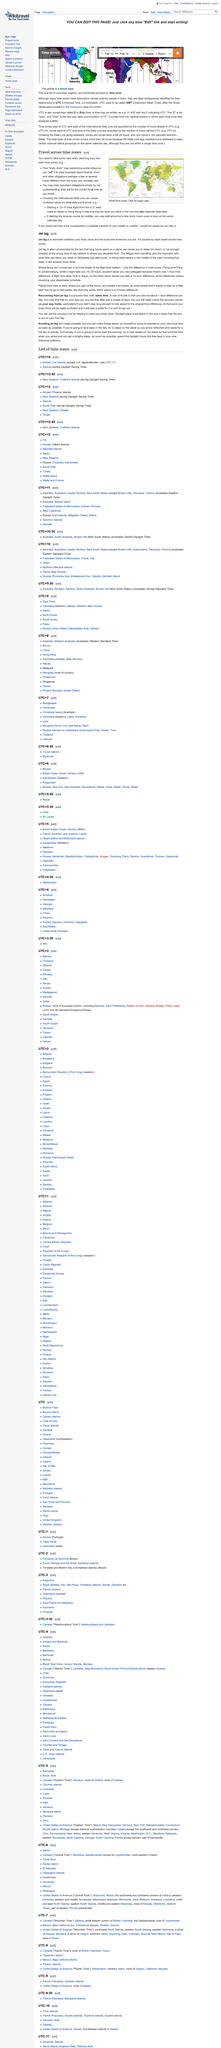Indicate a few pertinent items in this graphic. The image depicts a map of the world's time zones. The International Date Line can cause confusion for those traveling across it, as it can cause confusion about the date of arrival. When planning trips that span time zones, it is necessary to take care. 